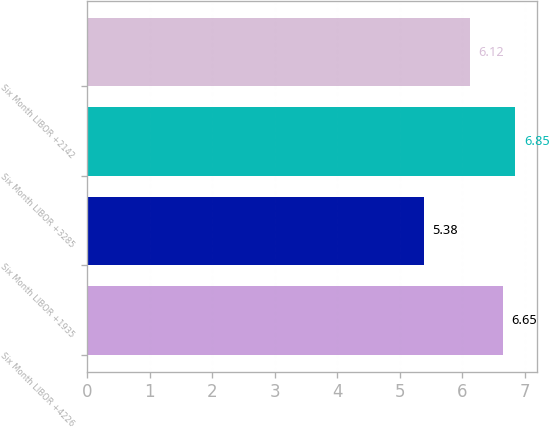Convert chart to OTSL. <chart><loc_0><loc_0><loc_500><loc_500><bar_chart><fcel>Six Month LIBOR +4226<fcel>Six Month LIBOR +1935<fcel>Six Month LIBOR +3285<fcel>Six Month LIBOR +2142<nl><fcel>6.65<fcel>5.38<fcel>6.85<fcel>6.12<nl></chart> 